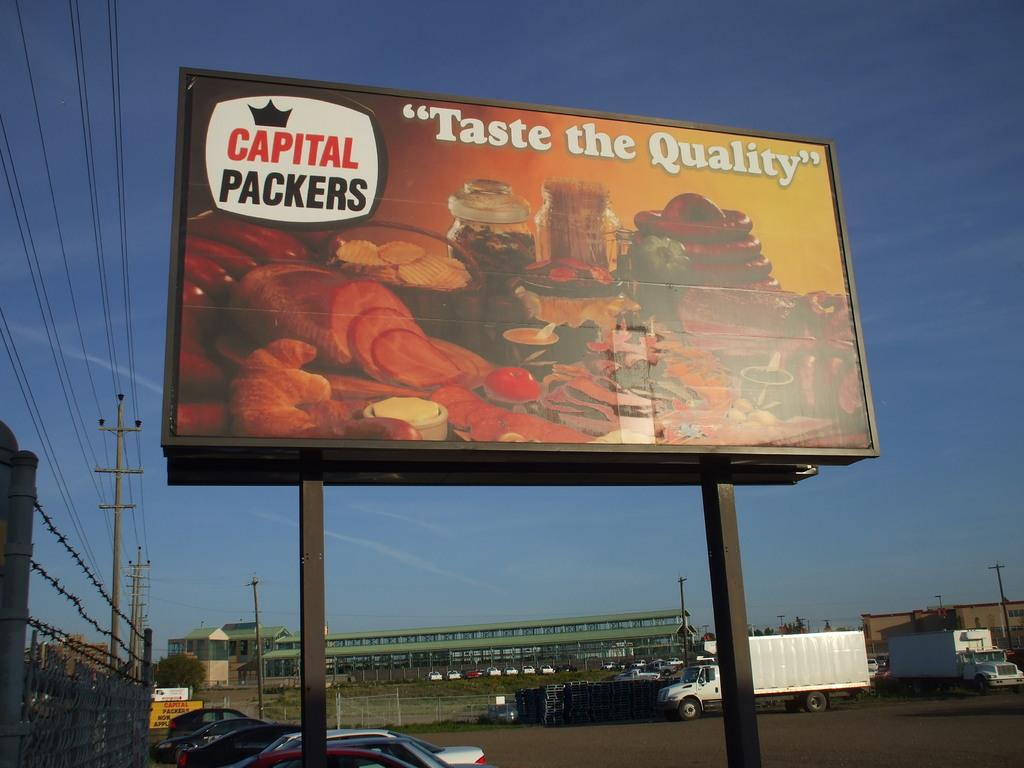<image>
Render a clear and concise summary of the photo. a large sign that says taste the quality on it 